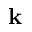<formula> <loc_0><loc_0><loc_500><loc_500>k</formula> 